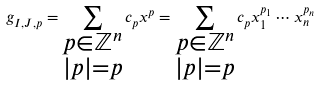Convert formula to latex. <formula><loc_0><loc_0><loc_500><loc_500>g _ { I , J , p } = \sum _ { \substack { p \in \mathbb { Z } ^ { n } \\ | p | = p } } c _ { p } x ^ { p } = \sum _ { \substack { p \in \mathbb { Z } ^ { n } \\ | p | = p } } c _ { p } x _ { 1 } ^ { p _ { 1 } } \cdots x _ { n } ^ { p _ { n } }</formula> 